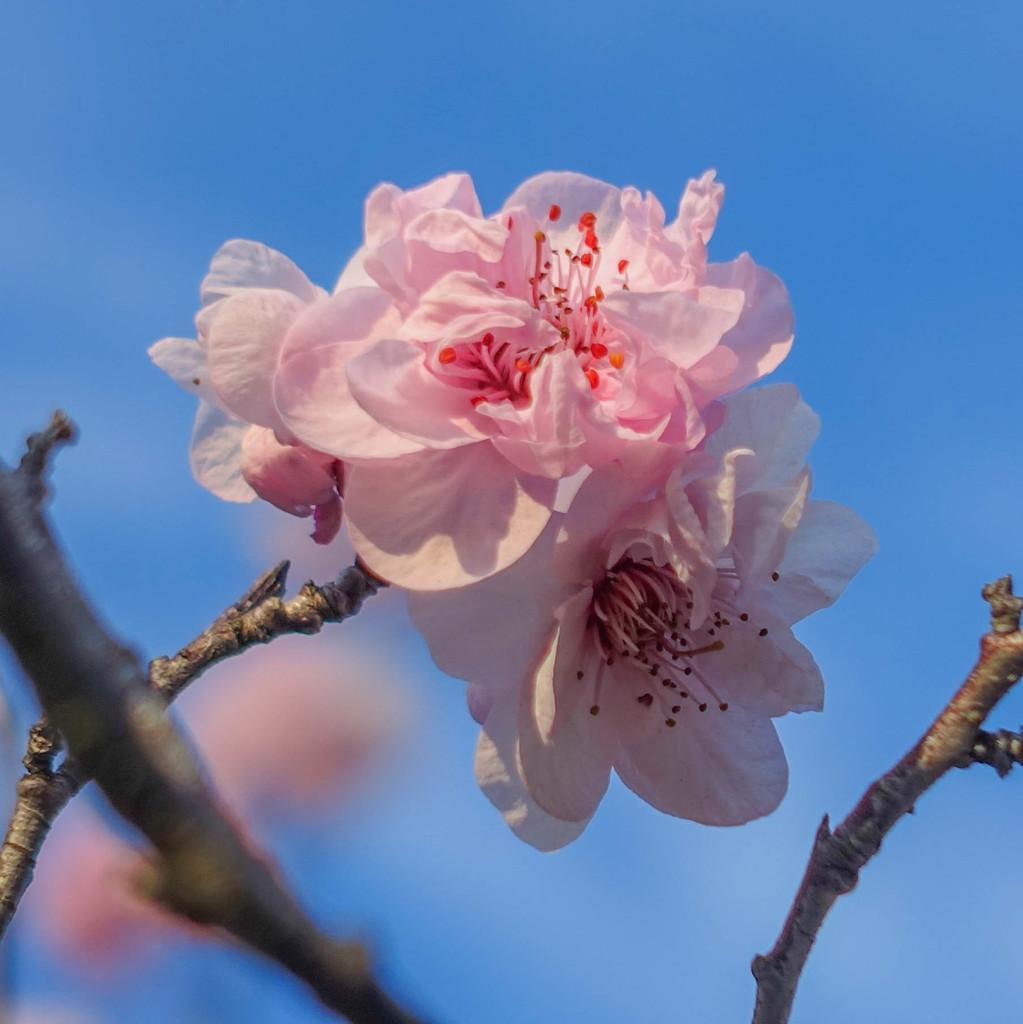Could you give a brief overview of what you see in this image? In this picture we can see a bunch of flowers and stems. Behind the flowers there is a sky and some blurred things. 